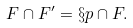Convert formula to latex. <formula><loc_0><loc_0><loc_500><loc_500>F \cap F ^ { \prime } = \S p \cap F .</formula> 